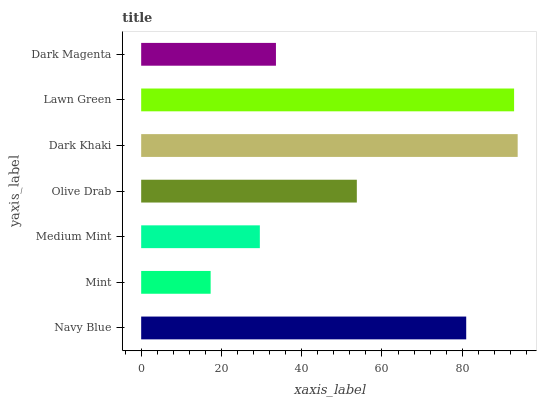Is Mint the minimum?
Answer yes or no. Yes. Is Dark Khaki the maximum?
Answer yes or no. Yes. Is Medium Mint the minimum?
Answer yes or no. No. Is Medium Mint the maximum?
Answer yes or no. No. Is Medium Mint greater than Mint?
Answer yes or no. Yes. Is Mint less than Medium Mint?
Answer yes or no. Yes. Is Mint greater than Medium Mint?
Answer yes or no. No. Is Medium Mint less than Mint?
Answer yes or no. No. Is Olive Drab the high median?
Answer yes or no. Yes. Is Olive Drab the low median?
Answer yes or no. Yes. Is Mint the high median?
Answer yes or no. No. Is Medium Mint the low median?
Answer yes or no. No. 